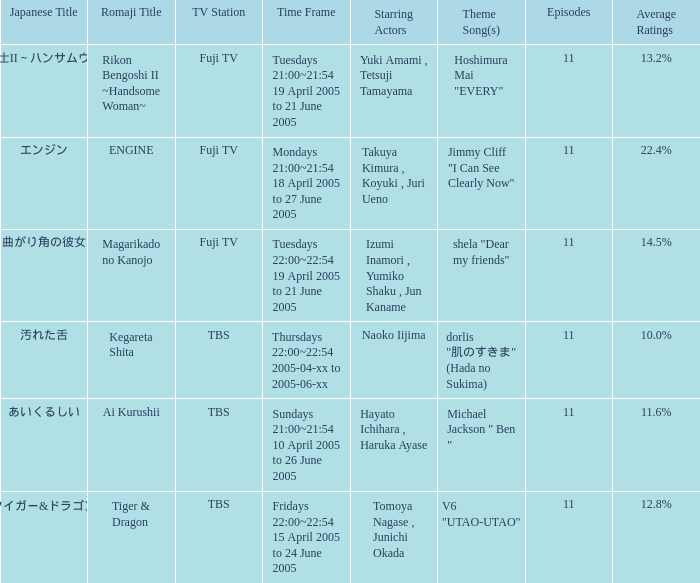What is the main song associated with the magarikado no kanojo series? Shela "dear my friends". 